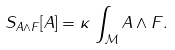<formula> <loc_0><loc_0><loc_500><loc_500>S _ { A \wedge F } [ A ] = \kappa \, \int _ { \mathcal { M } } A \wedge F .</formula> 